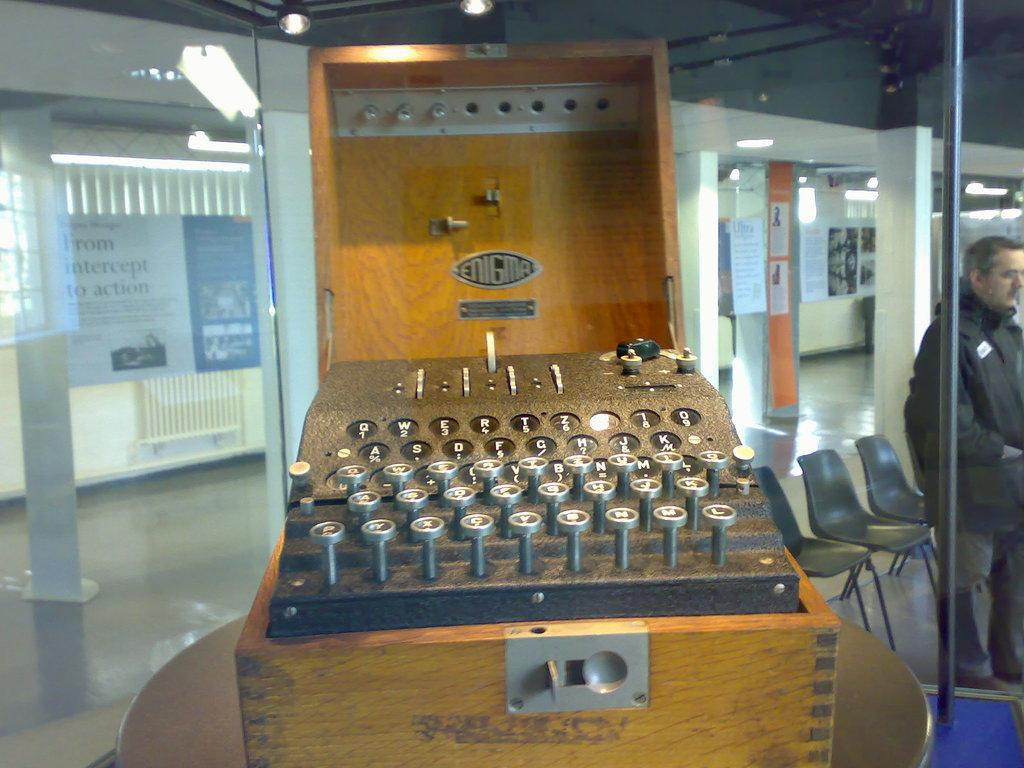<image>
Present a compact description of the photo's key features. an old enigma cipher machine on display somewhere 